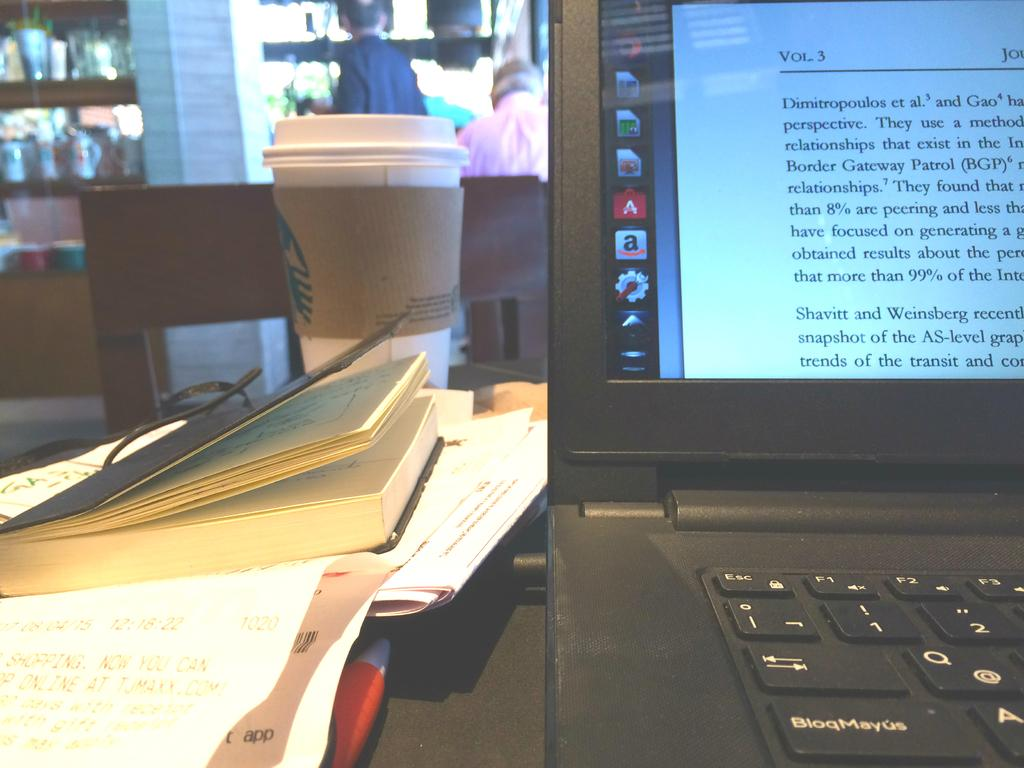What electronic device is visible in the image? There is a laptop in the image. Where is the laptop positioned in relation to the image? The laptop is in front of the image. What other object is located behind the laptop? There is a book behind the laptop. What beverage is present in the image? There is a coffee glass in the image. Can you describe the people in the background of the image? There are people standing in the background of the image. What type of magic is being performed with the quince in the image? There is no quince or magic present in the image; it features a laptop, a book, a coffee glass, and people in the background. 